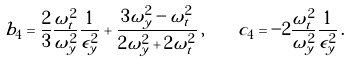<formula> <loc_0><loc_0><loc_500><loc_500>b _ { 4 } = \frac { 2 } { 3 } \frac { \omega _ { t } ^ { 2 } } { \omega _ { y } ^ { 2 } } \frac { 1 } { \epsilon _ { y } ^ { 2 } } + \frac { 3 \omega _ { y } ^ { 2 } - \omega _ { t } ^ { 2 } } { 2 \omega _ { y } ^ { 2 } + 2 \omega _ { t } ^ { 2 } } \, , \quad c _ { 4 } = - 2 \frac { \omega _ { t } ^ { 2 } } { \omega _ { y } ^ { 2 } } \frac { 1 } { \epsilon _ { y } ^ { 2 } } \, .</formula> 